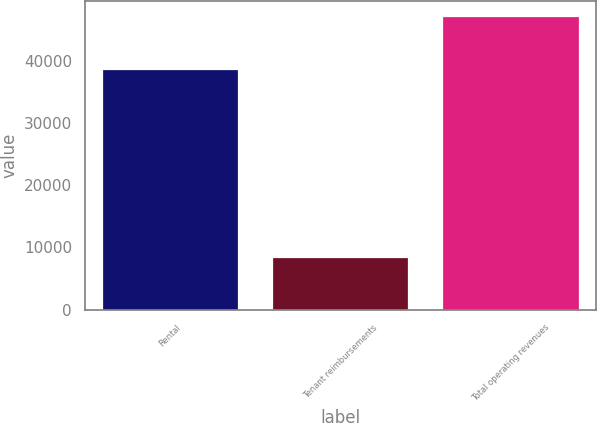Convert chart to OTSL. <chart><loc_0><loc_0><loc_500><loc_500><bar_chart><fcel>Rental<fcel>Tenant reimbursements<fcel>Total operating revenues<nl><fcel>38705<fcel>8423<fcel>47128<nl></chart> 